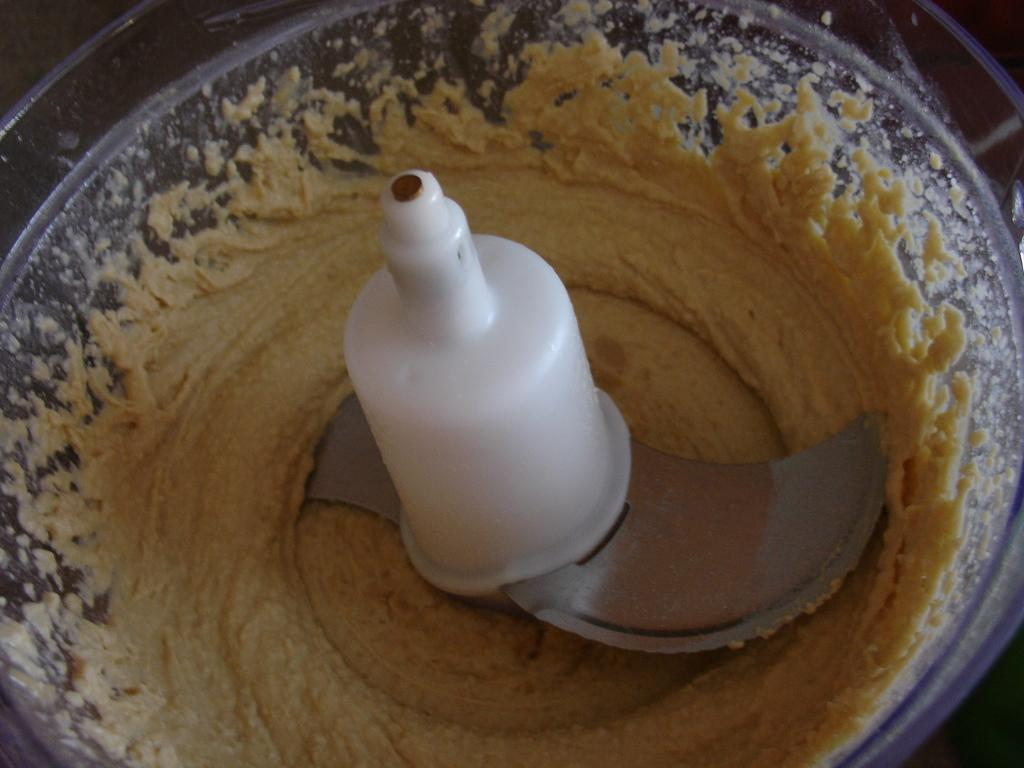What object is the main focus of the image? The main focus of the image is a grinder jar. What is inside the grinder jar? The grinder jar contains paste. How much debt is associated with the grinder jar in the image? There is no mention of debt in the image, as it features a grinder jar containing paste. What type of rake is shown being used with the grinder jar in the image? There is no rake present in the image; it only features a grinder jar with paste. 